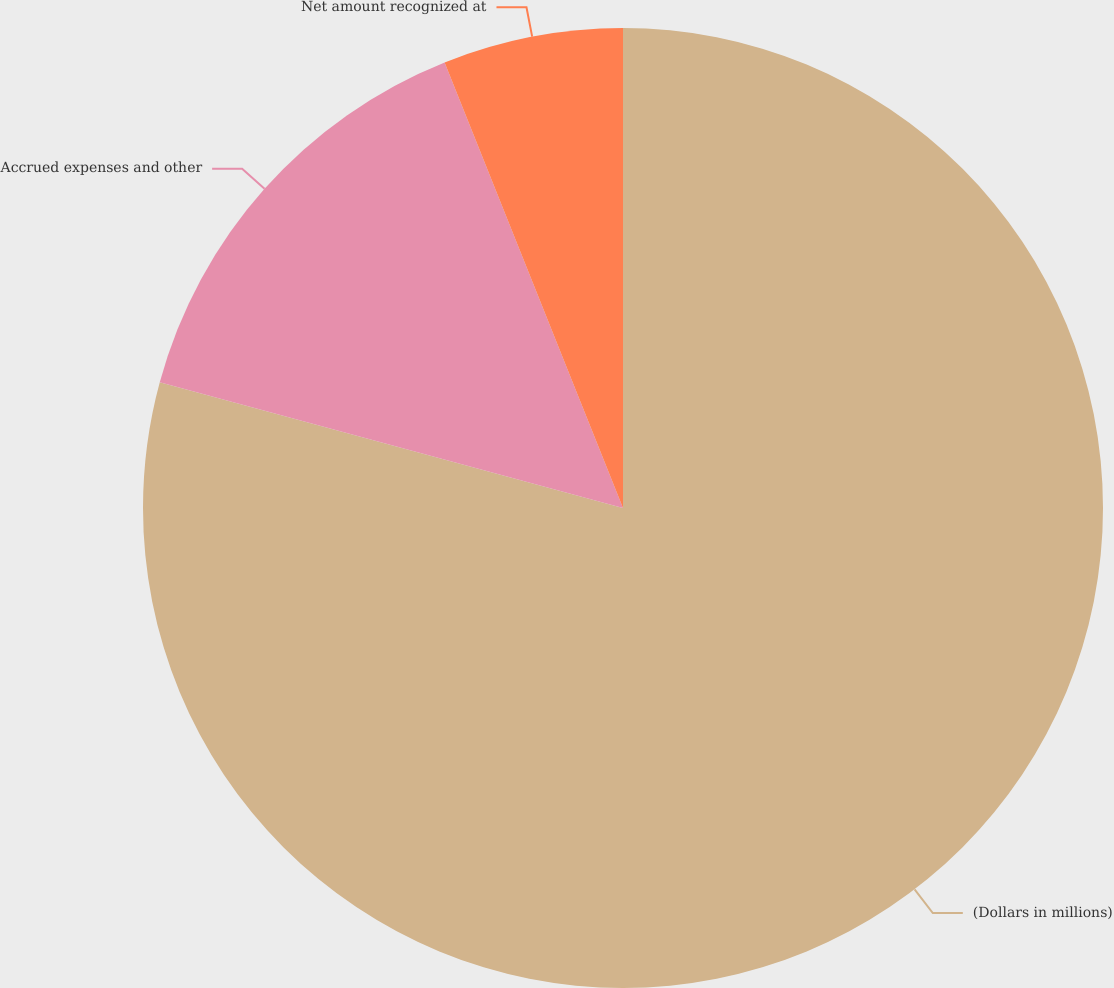<chart> <loc_0><loc_0><loc_500><loc_500><pie_chart><fcel>(Dollars in millions)<fcel>Accrued expenses and other<fcel>Net amount recognized at<nl><fcel>79.21%<fcel>14.72%<fcel>6.06%<nl></chart> 